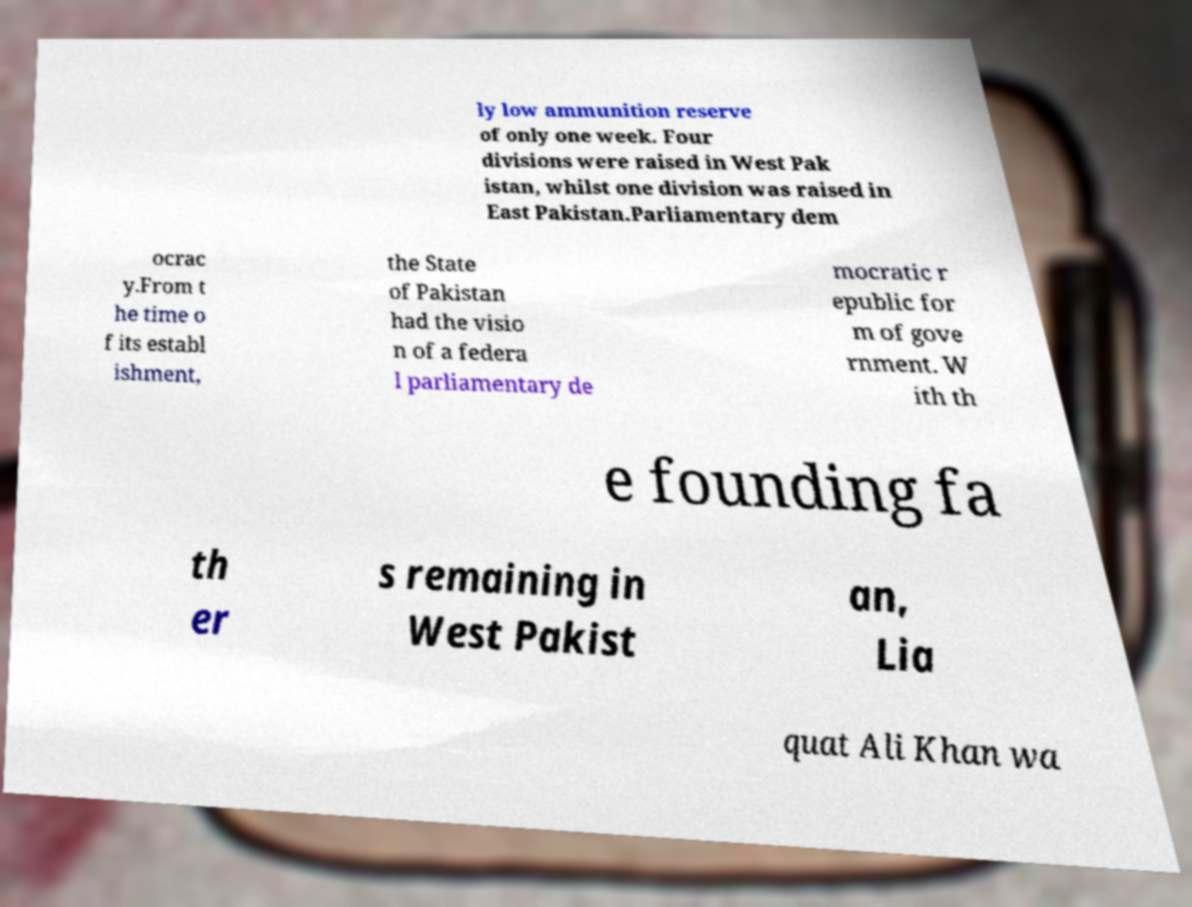Can you accurately transcribe the text from the provided image for me? ly low ammunition reserve of only one week. Four divisions were raised in West Pak istan, whilst one division was raised in East Pakistan.Parliamentary dem ocrac y.From t he time o f its establ ishment, the State of Pakistan had the visio n of a federa l parliamentary de mocratic r epublic for m of gove rnment. W ith th e founding fa th er s remaining in West Pakist an, Lia quat Ali Khan wa 